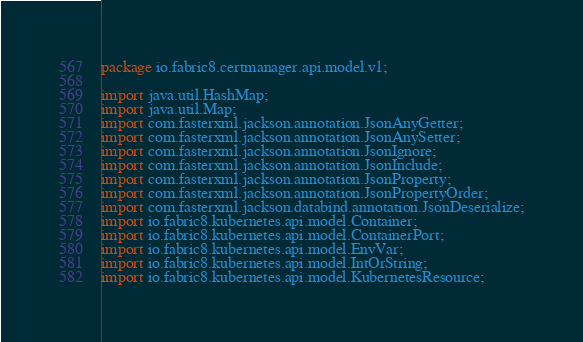Convert code to text. <code><loc_0><loc_0><loc_500><loc_500><_Java_>
package io.fabric8.certmanager.api.model.v1;

import java.util.HashMap;
import java.util.Map;
import com.fasterxml.jackson.annotation.JsonAnyGetter;
import com.fasterxml.jackson.annotation.JsonAnySetter;
import com.fasterxml.jackson.annotation.JsonIgnore;
import com.fasterxml.jackson.annotation.JsonInclude;
import com.fasterxml.jackson.annotation.JsonProperty;
import com.fasterxml.jackson.annotation.JsonPropertyOrder;
import com.fasterxml.jackson.databind.annotation.JsonDeserialize;
import io.fabric8.kubernetes.api.model.Container;
import io.fabric8.kubernetes.api.model.ContainerPort;
import io.fabric8.kubernetes.api.model.EnvVar;
import io.fabric8.kubernetes.api.model.IntOrString;
import io.fabric8.kubernetes.api.model.KubernetesResource;</code> 